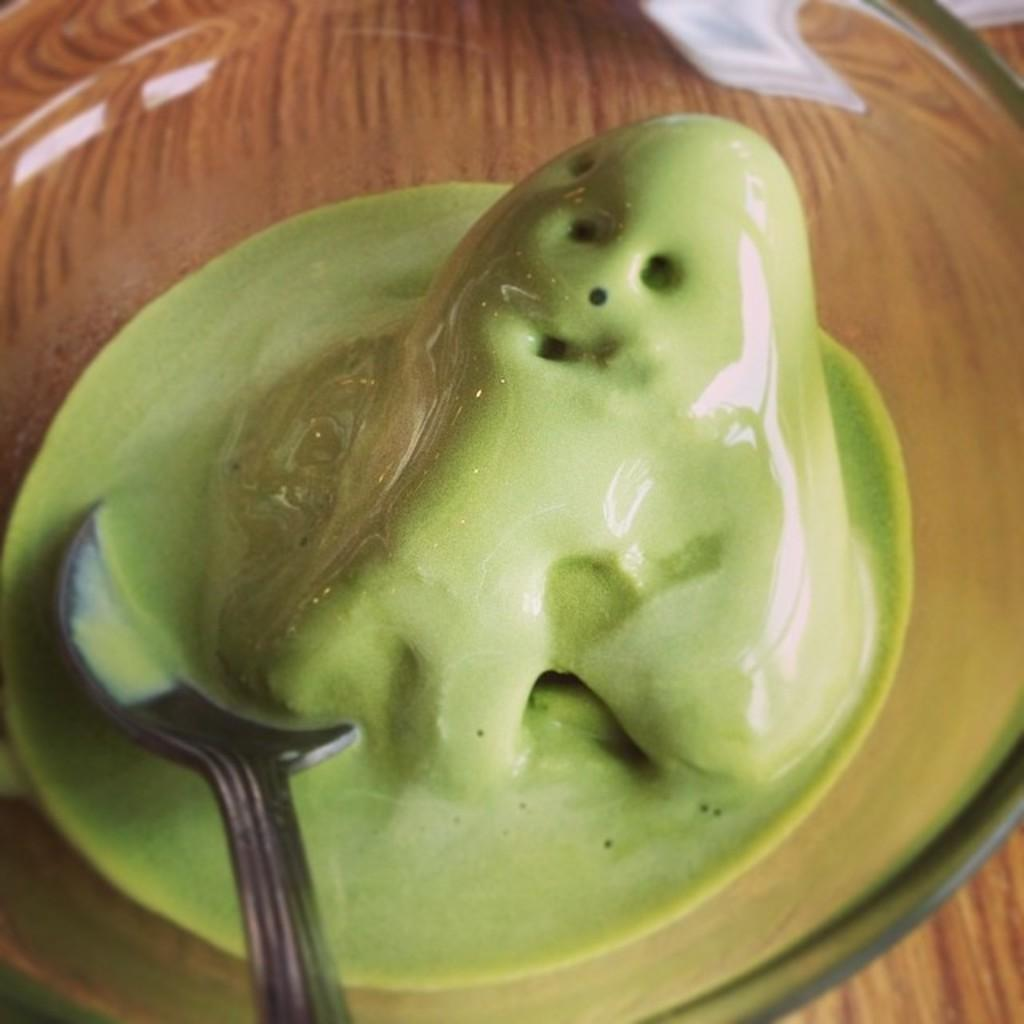What type of container is holding the food in the image? The food is in a glass bowl. What is inside the glass bowl with the food? A spoon is in the glass bowl. What is the color of the food in the image? The food is green in color. On what surface is the glass bowl placed? The glass bowl is on a brown surface. What type of wool is being used to make the food in the image? There is no wool present in the image, and the food is not made of wool. 